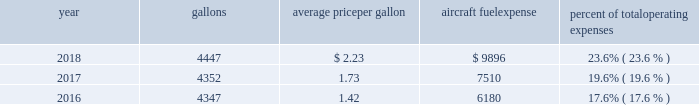The table shows annual aircraft fuel consumption and costs , including taxes , for our mainline and regional operations for 2018 , 2017 and 2016 ( gallons and aircraft fuel expense in millions ) .
Year gallons average price per gallon aircraft fuel expense percent of total operating expenses .
As of december 31 , 2018 , we did not have any fuel hedging contracts outstanding to hedge our fuel consumption .
As such , and assuming we do not enter into any future transactions to hedge our fuel consumption , we will continue to be fully exposed to fluctuations in fuel prices .
Our current policy is not to enter into transactions to hedge our fuel consumption , although we review that policy from time to time based on market conditions and other factors .
Fuel prices have fluctuated substantially over the past several years .
We cannot predict the future availability , price volatility or cost of aircraft fuel .
Natural disasters ( including hurricanes or similar events in the u.s .
Southeast and on the gulf coast where a significant portion of domestic refining capacity is located ) , political disruptions or wars involving oil-producing countries , economic sanctions imposed against oil-producing countries or specific industry participants , changes in fuel-related governmental policy , the strength of the u.s .
Dollar against foreign currencies , changes in the cost to transport or store petroleum products , changes in access to petroleum product pipelines and terminals , speculation in the energy futures markets , changes in aircraft fuel production capacity , environmental concerns and other unpredictable events may result in fuel supply shortages , distribution challenges , additional fuel price volatility and cost increases in the future .
See part i , item 1a .
Risk factors 2013 201cour business is very dependent on the price and availability of aircraft fuel .
Continued periods of high volatility in fuel costs , increased fuel prices or significant disruptions in the supply of aircraft fuel could have a significant negative impact on our operating results and liquidity . 201d seasonality and other factors due to the greater demand for air travel during the summer months , revenues in the airline industry in the second and third quarters of the year tend to be greater than revenues in the first and fourth quarters of the year .
General economic conditions , fears of terrorism or war , fare initiatives , fluctuations in fuel prices , labor actions , weather , natural disasters , outbreaks of disease and other factors could impact this seasonal pattern .
Therefore , our quarterly results of operations are not necessarily indicative of operating results for the entire year , and historical operating results in a quarterly or annual period are not necessarily indicative of future operating results .
Domestic and global regulatory landscape general airlines are subject to extensive domestic and international regulatory requirements .
Domestically , the dot and the federal aviation administration ( faa ) exercise significant regulatory authority over air carriers .
The dot , among other things , oversees domestic and international codeshare agreements , international route authorities , competition and consumer protection matters such as advertising , denied boarding compensation and baggage liability .
The antitrust division of the department of justice ( doj ) , along with the dot in certain instances , have jurisdiction over airline antitrust matters. .
What were total operating expenses in 2018? 
Computations: (9896 / 23.6%)
Answer: 41932.20339. 